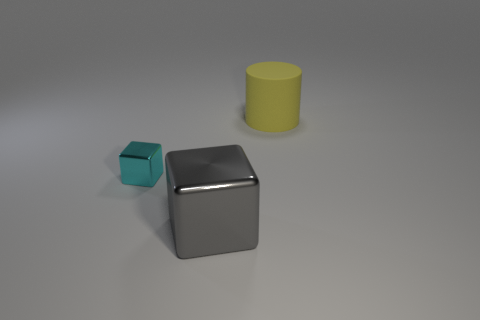Is there any other thing that is made of the same material as the cylinder?
Give a very brief answer. No. Are there any other large shiny objects that have the same color as the big metallic object?
Make the answer very short. No. What number of objects are either big objects that are to the left of the large yellow object or big blue matte spheres?
Your response must be concise. 1. The tiny block that is the same material as the large gray object is what color?
Make the answer very short. Cyan. Are there any other metallic things that have the same size as the yellow thing?
Your response must be concise. Yes. How many objects are either things that are to the left of the big metal cube or big objects behind the small block?
Your response must be concise. 2. There is another thing that is the same size as the gray thing; what is its shape?
Keep it short and to the point. Cylinder. Are there any cyan things of the same shape as the gray shiny thing?
Your answer should be compact. Yes. Are there fewer large gray things than large things?
Your answer should be compact. Yes. Does the object on the right side of the gray metallic object have the same size as the thing that is in front of the tiny cyan cube?
Provide a succinct answer. Yes. 